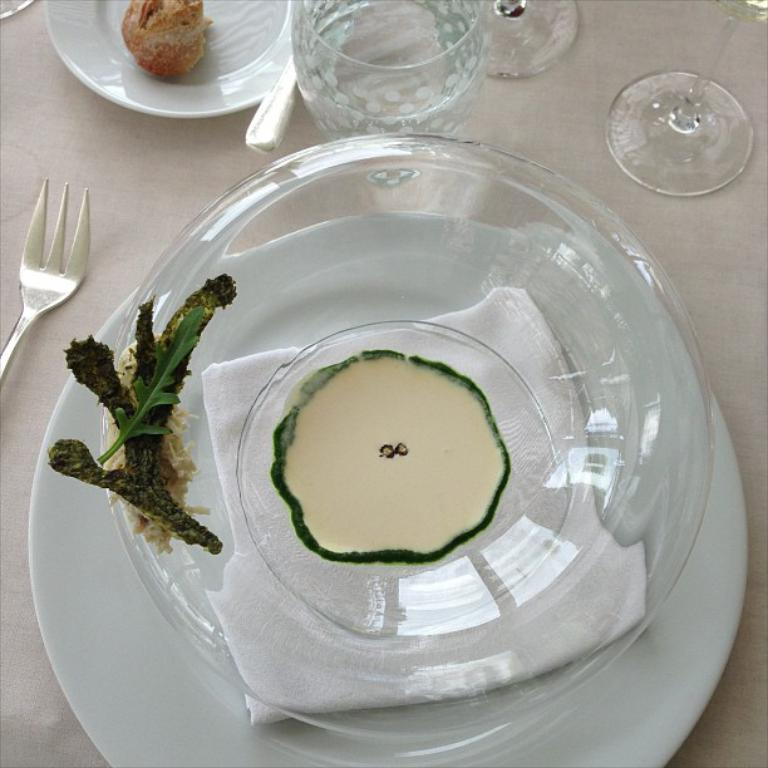What piece of furniture is present in the image? There is a table in the image. What items are placed on the table? There are plates, glasses, bowls, lids, and forks on the table. What type of food items can be seen on the table? There are food items on the table. Can you see a maid cleaning the table in the image? There is no maid present in the image. Is the table located on a hill in the image? The image does not show any hills or elevated terrain; it only shows a table with various items on it. 